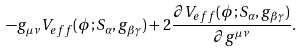Convert formula to latex. <formula><loc_0><loc_0><loc_500><loc_500>- g _ { \mu \nu } V _ { e f f } ( \phi ; S _ { \alpha } , g _ { \beta \gamma } ) + 2 \frac { \partial V _ { e f f } ( \phi ; S _ { \alpha } , g _ { \beta \gamma } ) } { \partial g ^ { \mu \nu } } .</formula> 